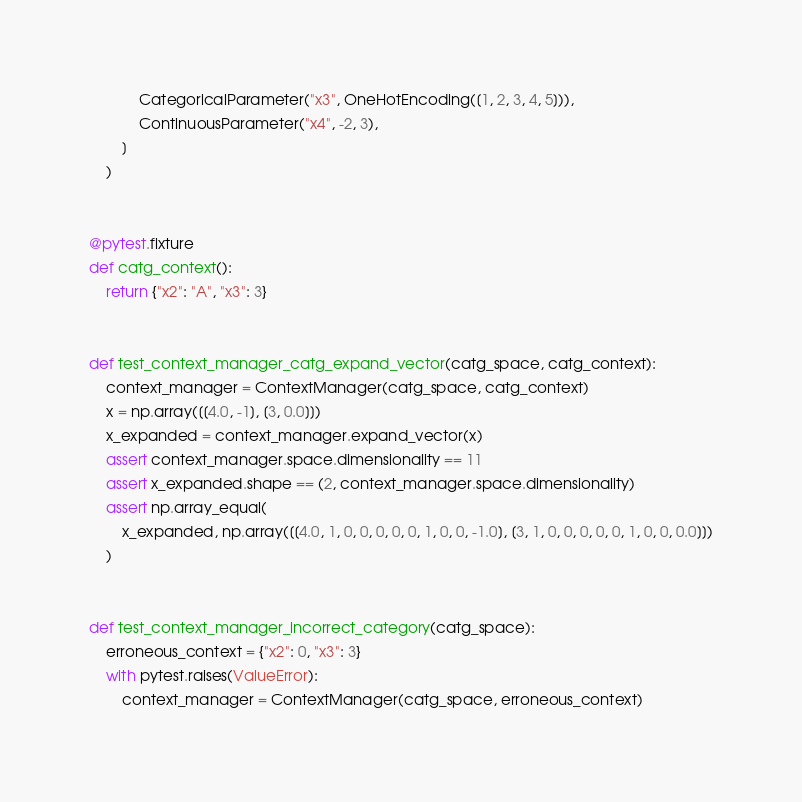Convert code to text. <code><loc_0><loc_0><loc_500><loc_500><_Python_>            CategoricalParameter("x3", OneHotEncoding([1, 2, 3, 4, 5])),
            ContinuousParameter("x4", -2, 3),
        ]
    )


@pytest.fixture
def catg_context():
    return {"x2": "A", "x3": 3}


def test_context_manager_catg_expand_vector(catg_space, catg_context):
    context_manager = ContextManager(catg_space, catg_context)
    x = np.array([[4.0, -1], [3, 0.0]])
    x_expanded = context_manager.expand_vector(x)
    assert context_manager.space.dimensionality == 11
    assert x_expanded.shape == (2, context_manager.space.dimensionality)
    assert np.array_equal(
        x_expanded, np.array([[4.0, 1, 0, 0, 0, 0, 0, 1, 0, 0, -1.0], [3, 1, 0, 0, 0, 0, 0, 1, 0, 0, 0.0]])
    )


def test_context_manager_incorrect_category(catg_space):
    erroneous_context = {"x2": 0, "x3": 3}
    with pytest.raises(ValueError):
        context_manager = ContextManager(catg_space, erroneous_context)
</code> 